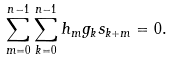<formula> <loc_0><loc_0><loc_500><loc_500>\sum _ { m = 0 } ^ { n - 1 } \sum _ { k = 0 } ^ { n - 1 } h _ { m } g _ { k } s _ { k + m } = 0 .</formula> 